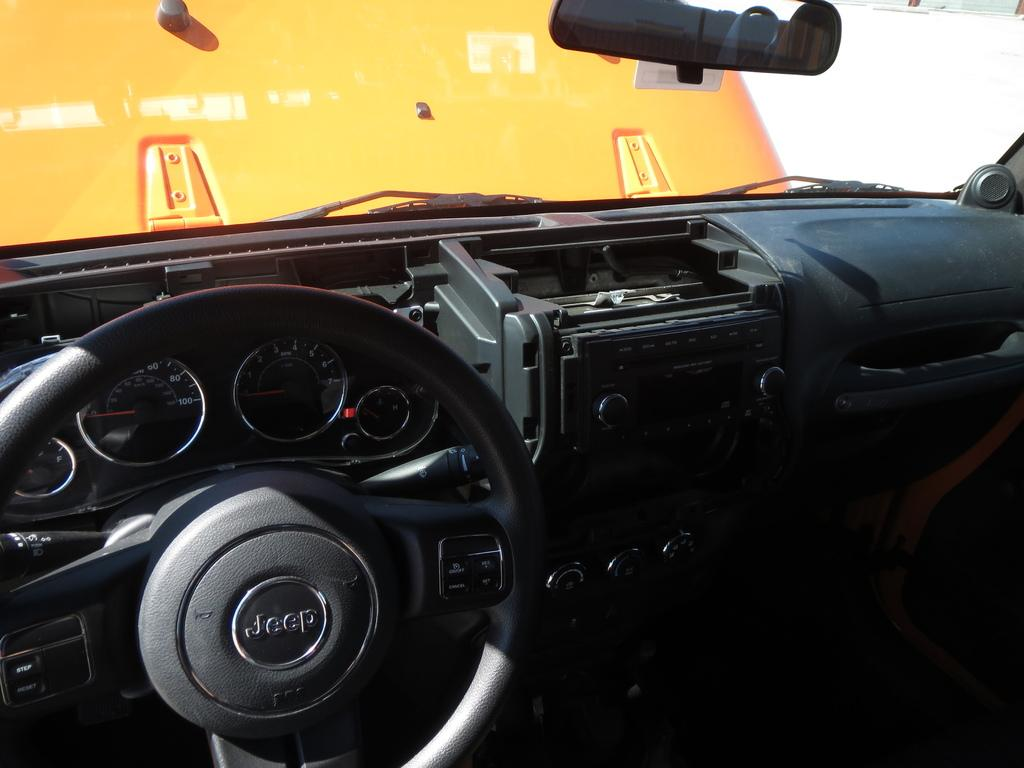What type of setting is depicted in the image? The image shows the interior of a motor vehicle. What type of thread is being used to sew the letter onto the dashboard of the motor vehicle? There is no thread or letter present in the image, as it only shows the interior of a motor vehicle. 